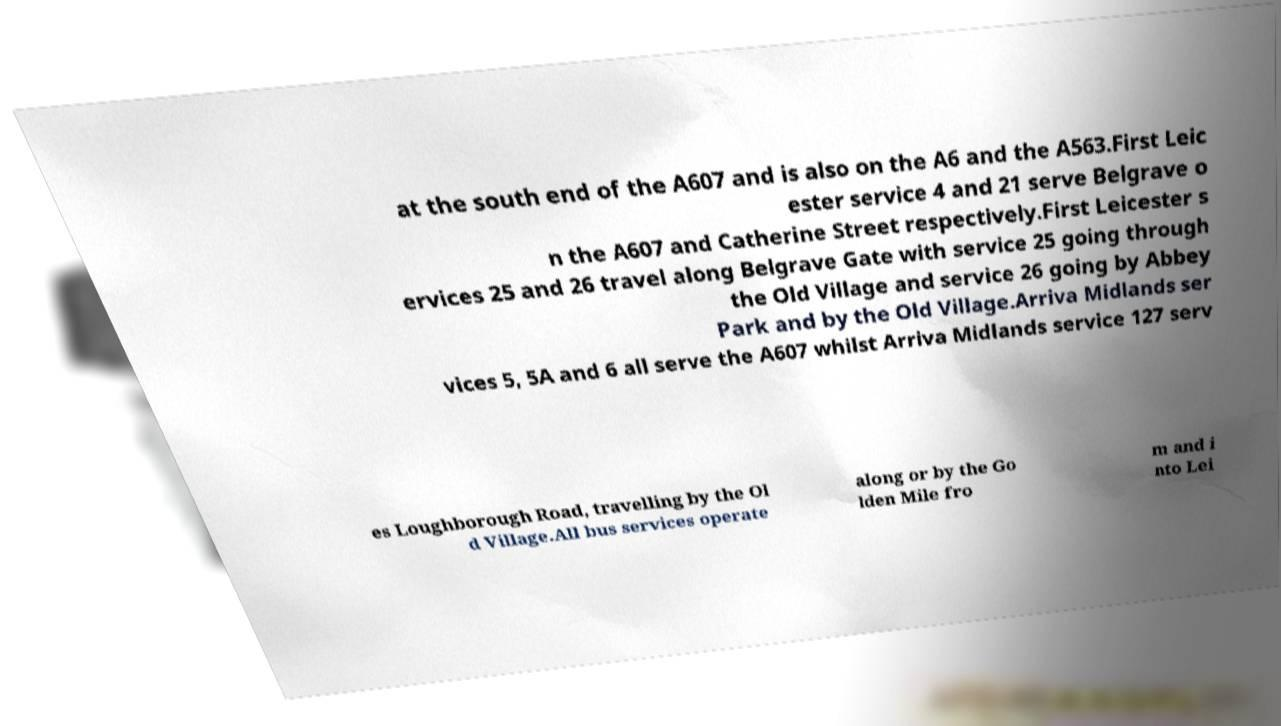What messages or text are displayed in this image? I need them in a readable, typed format. at the south end of the A607 and is also on the A6 and the A563.First Leic ester service 4 and 21 serve Belgrave o n the A607 and Catherine Street respectively.First Leicester s ervices 25 and 26 travel along Belgrave Gate with service 25 going through the Old Village and service 26 going by Abbey Park and by the Old Village.Arriva Midlands ser vices 5, 5A and 6 all serve the A607 whilst Arriva Midlands service 127 serv es Loughborough Road, travelling by the Ol d Village.All bus services operate along or by the Go lden Mile fro m and i nto Lei 